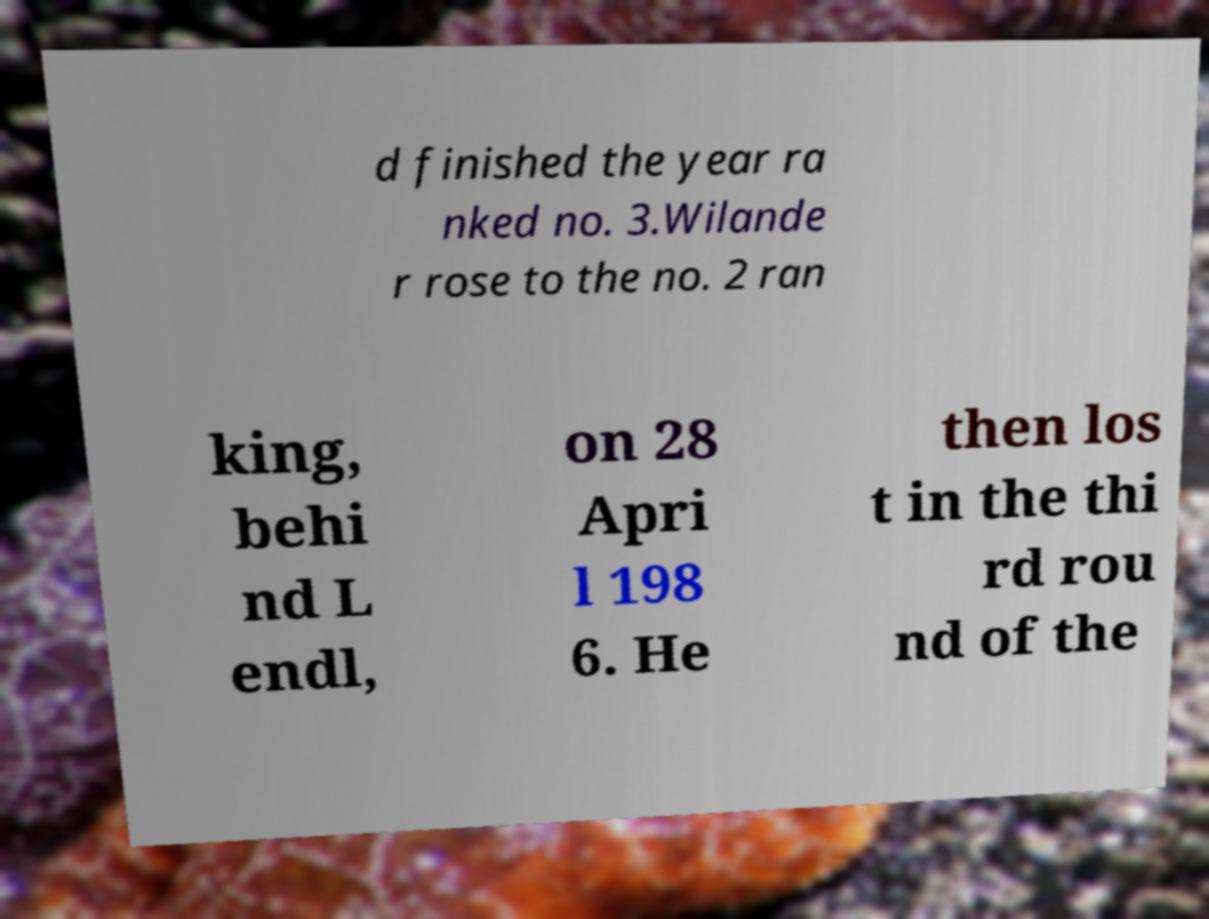For documentation purposes, I need the text within this image transcribed. Could you provide that? d finished the year ra nked no. 3.Wilande r rose to the no. 2 ran king, behi nd L endl, on 28 Apri l 198 6. He then los t in the thi rd rou nd of the 